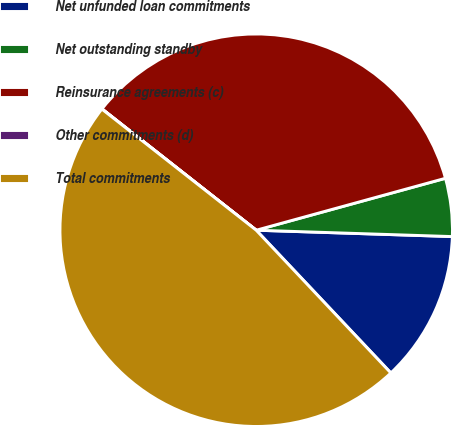Convert chart to OTSL. <chart><loc_0><loc_0><loc_500><loc_500><pie_chart><fcel>Net unfunded loan commitments<fcel>Net outstanding standby<fcel>Reinsurance agreements (c)<fcel>Other commitments (d)<fcel>Total commitments<nl><fcel>12.45%<fcel>4.78%<fcel>35.13%<fcel>0.02%<fcel>47.63%<nl></chart> 